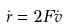<formula> <loc_0><loc_0><loc_500><loc_500>\dot { r } = 2 F \dot { v }</formula> 